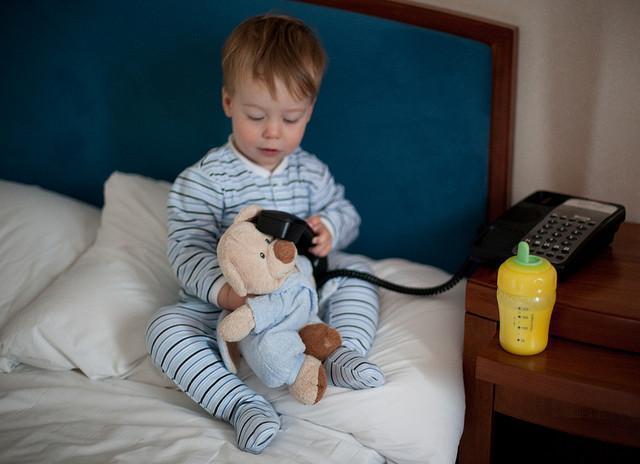What does the child imagine his toy bear does now?
Select the correct answer and articulate reasoning with the following format: 'Answer: answer
Rationale: rationale.'
Options: Eat honey, phone call, make house, sing song. Answer: phone call.
Rationale: The child has his toy bear make a phone call. 